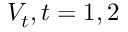<formula> <loc_0><loc_0><loc_500><loc_500>V _ { t } , t = 1 , 2</formula> 